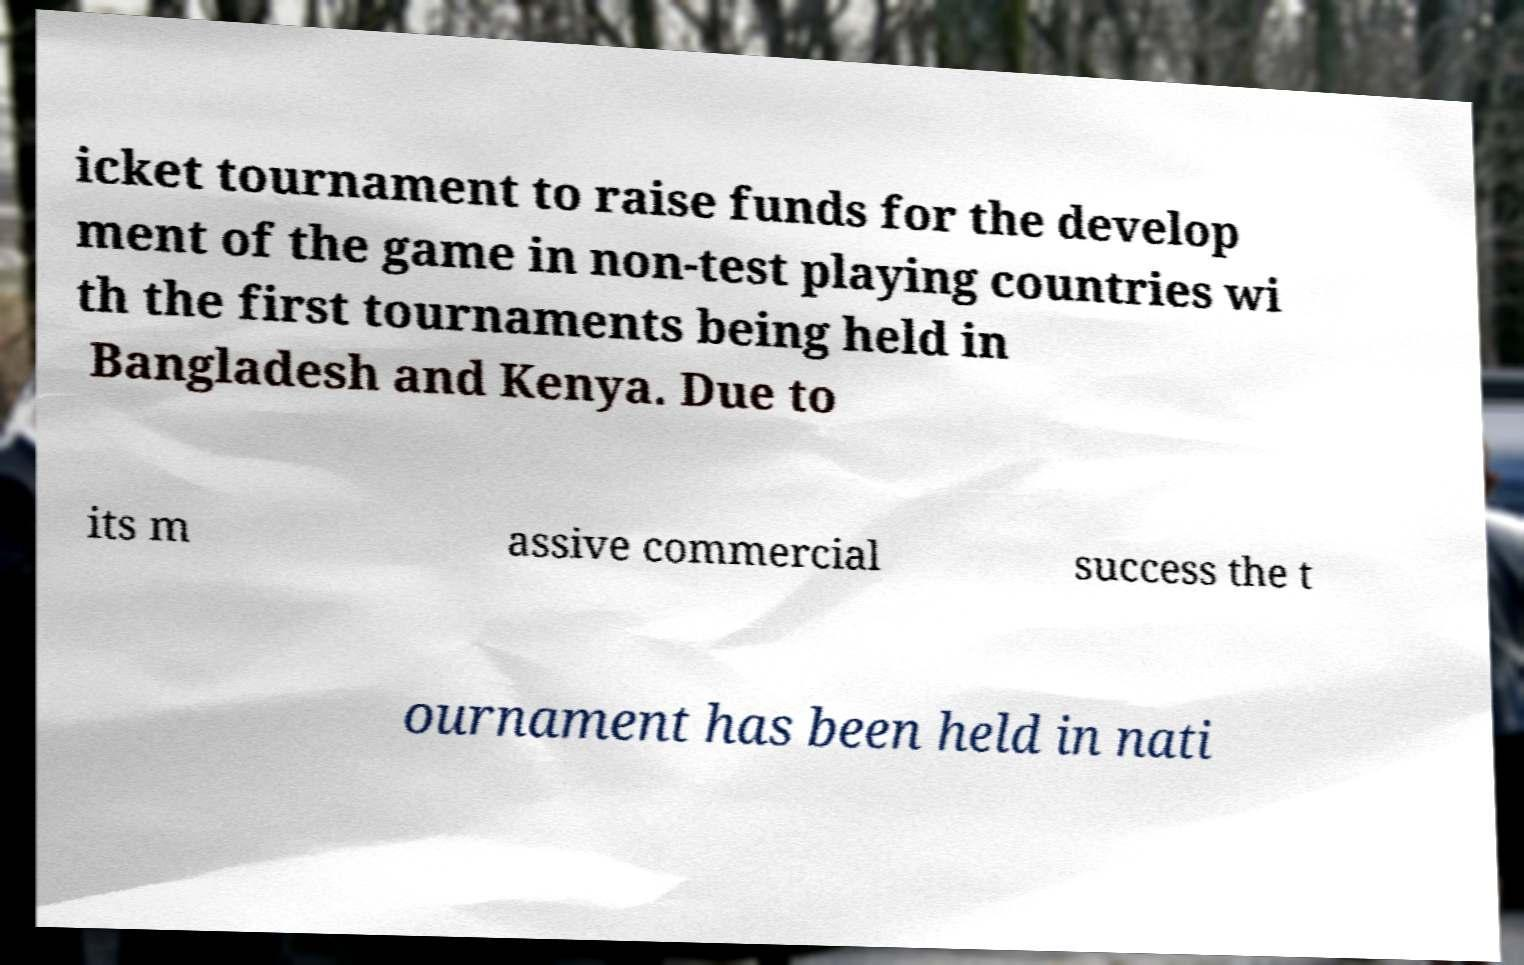Could you assist in decoding the text presented in this image and type it out clearly? icket tournament to raise funds for the develop ment of the game in non-test playing countries wi th the first tournaments being held in Bangladesh and Kenya. Due to its m assive commercial success the t ournament has been held in nati 